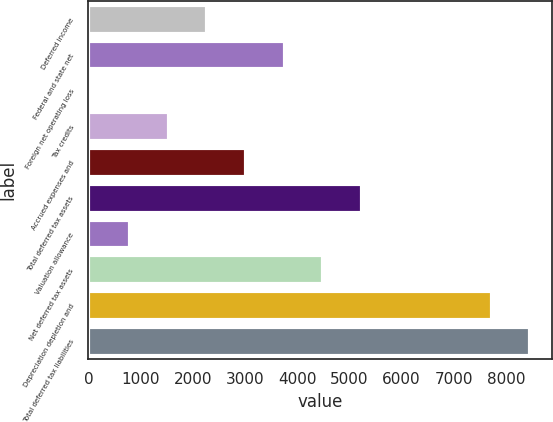Convert chart to OTSL. <chart><loc_0><loc_0><loc_500><loc_500><bar_chart><fcel>Deferred income<fcel>Federal and state net<fcel>Foreign net operating loss<fcel>Tax credits<fcel>Accrued expenses and<fcel>Total deferred tax assets<fcel>Valuation allowance<fcel>Net deferred tax assets<fcel>Depreciation depletion and<fcel>Total deferred tax liabilities<nl><fcel>2277.7<fcel>3759.5<fcel>55<fcel>1536.8<fcel>3018.6<fcel>5241.3<fcel>795.9<fcel>4500.4<fcel>7728.9<fcel>8469.8<nl></chart> 